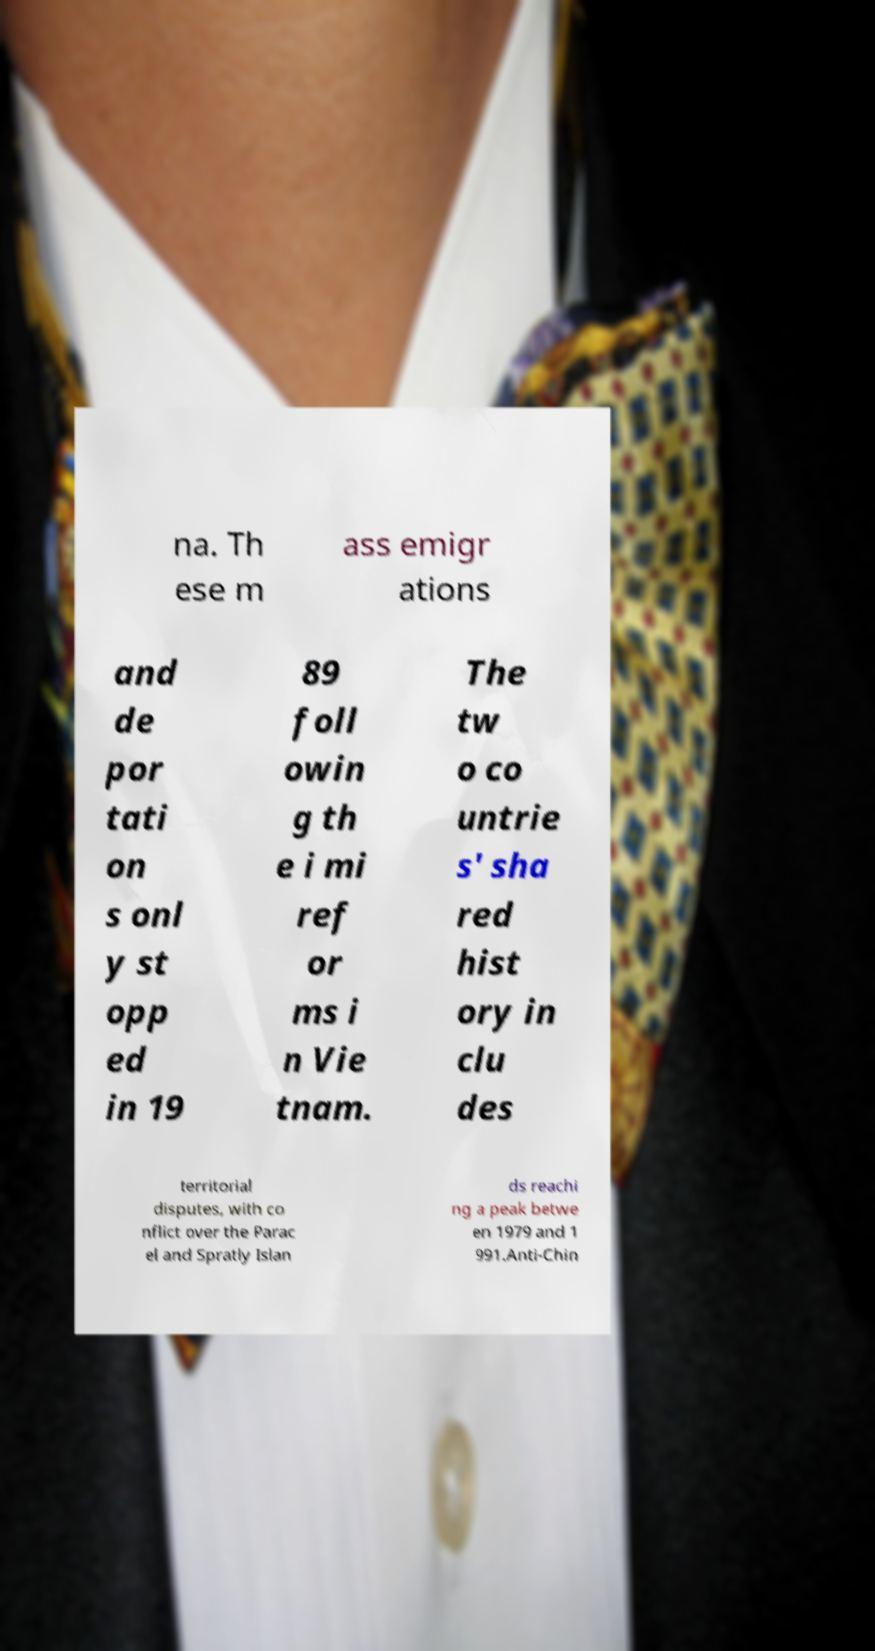I need the written content from this picture converted into text. Can you do that? na. Th ese m ass emigr ations and de por tati on s onl y st opp ed in 19 89 foll owin g th e i mi ref or ms i n Vie tnam. The tw o co untrie s' sha red hist ory in clu des territorial disputes, with co nflict over the Parac el and Spratly Islan ds reachi ng a peak betwe en 1979 and 1 991.Anti-Chin 